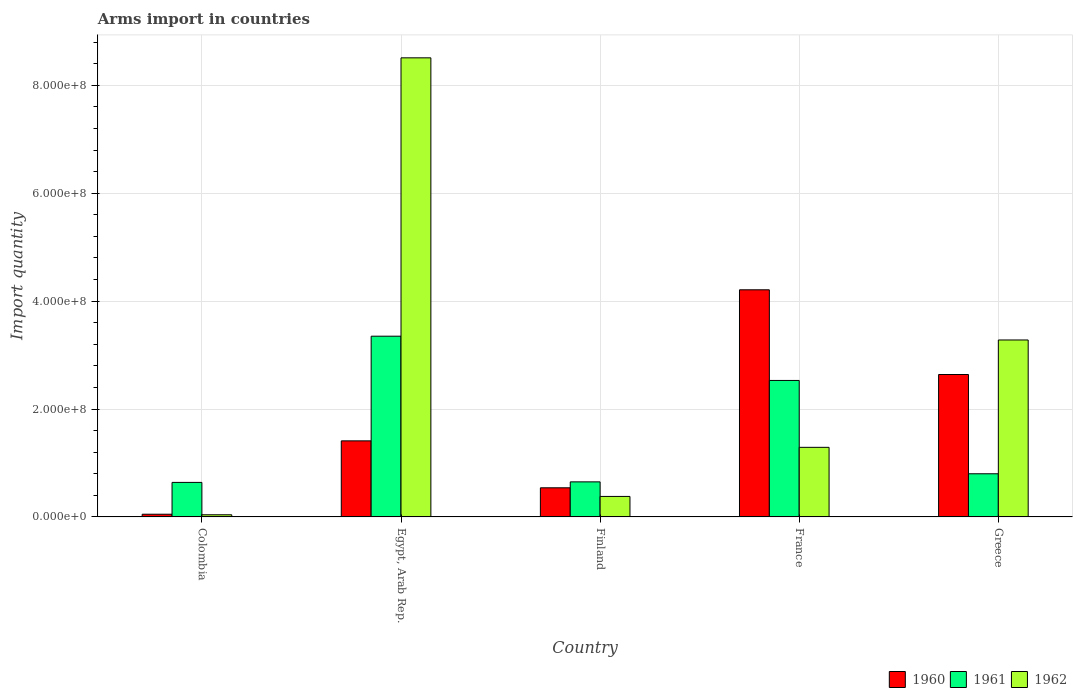How many different coloured bars are there?
Give a very brief answer. 3. How many groups of bars are there?
Keep it short and to the point. 5. Are the number of bars per tick equal to the number of legend labels?
Your answer should be compact. Yes. How many bars are there on the 5th tick from the left?
Offer a very short reply. 3. In how many cases, is the number of bars for a given country not equal to the number of legend labels?
Keep it short and to the point. 0. What is the total arms import in 1962 in Egypt, Arab Rep.?
Keep it short and to the point. 8.51e+08. Across all countries, what is the maximum total arms import in 1960?
Your response must be concise. 4.21e+08. In which country was the total arms import in 1962 maximum?
Give a very brief answer. Egypt, Arab Rep. What is the total total arms import in 1962 in the graph?
Make the answer very short. 1.35e+09. What is the difference between the total arms import in 1960 in Egypt, Arab Rep. and that in Finland?
Provide a short and direct response. 8.70e+07. What is the difference between the total arms import in 1961 in Greece and the total arms import in 1962 in Finland?
Your response must be concise. 4.20e+07. What is the average total arms import in 1960 per country?
Make the answer very short. 1.77e+08. What is the difference between the total arms import of/in 1960 and total arms import of/in 1962 in Egypt, Arab Rep.?
Your response must be concise. -7.10e+08. In how many countries, is the total arms import in 1961 greater than 120000000?
Offer a terse response. 2. What is the ratio of the total arms import in 1962 in Finland to that in France?
Give a very brief answer. 0.29. Is the total arms import in 1960 in Colombia less than that in France?
Provide a short and direct response. Yes. What is the difference between the highest and the second highest total arms import in 1960?
Your response must be concise. 1.57e+08. What is the difference between the highest and the lowest total arms import in 1961?
Offer a terse response. 2.71e+08. In how many countries, is the total arms import in 1962 greater than the average total arms import in 1962 taken over all countries?
Keep it short and to the point. 2. Is the sum of the total arms import in 1961 in France and Greece greater than the maximum total arms import in 1962 across all countries?
Provide a short and direct response. No. What does the 3rd bar from the left in Egypt, Arab Rep. represents?
Keep it short and to the point. 1962. Is it the case that in every country, the sum of the total arms import in 1962 and total arms import in 1961 is greater than the total arms import in 1960?
Provide a short and direct response. No. Are all the bars in the graph horizontal?
Your answer should be compact. No. How many countries are there in the graph?
Provide a short and direct response. 5. What is the difference between two consecutive major ticks on the Y-axis?
Make the answer very short. 2.00e+08. Are the values on the major ticks of Y-axis written in scientific E-notation?
Offer a very short reply. Yes. Does the graph contain any zero values?
Your response must be concise. No. How many legend labels are there?
Provide a succinct answer. 3. What is the title of the graph?
Make the answer very short. Arms import in countries. Does "1977" appear as one of the legend labels in the graph?
Offer a very short reply. No. What is the label or title of the Y-axis?
Ensure brevity in your answer.  Import quantity. What is the Import quantity in 1961 in Colombia?
Offer a very short reply. 6.40e+07. What is the Import quantity in 1962 in Colombia?
Provide a succinct answer. 4.00e+06. What is the Import quantity in 1960 in Egypt, Arab Rep.?
Your response must be concise. 1.41e+08. What is the Import quantity of 1961 in Egypt, Arab Rep.?
Make the answer very short. 3.35e+08. What is the Import quantity in 1962 in Egypt, Arab Rep.?
Your answer should be compact. 8.51e+08. What is the Import quantity of 1960 in Finland?
Make the answer very short. 5.40e+07. What is the Import quantity in 1961 in Finland?
Your answer should be very brief. 6.50e+07. What is the Import quantity in 1962 in Finland?
Offer a very short reply. 3.80e+07. What is the Import quantity in 1960 in France?
Make the answer very short. 4.21e+08. What is the Import quantity in 1961 in France?
Your response must be concise. 2.53e+08. What is the Import quantity of 1962 in France?
Give a very brief answer. 1.29e+08. What is the Import quantity in 1960 in Greece?
Ensure brevity in your answer.  2.64e+08. What is the Import quantity in 1961 in Greece?
Provide a short and direct response. 8.00e+07. What is the Import quantity in 1962 in Greece?
Give a very brief answer. 3.28e+08. Across all countries, what is the maximum Import quantity of 1960?
Offer a very short reply. 4.21e+08. Across all countries, what is the maximum Import quantity of 1961?
Keep it short and to the point. 3.35e+08. Across all countries, what is the maximum Import quantity of 1962?
Ensure brevity in your answer.  8.51e+08. Across all countries, what is the minimum Import quantity of 1961?
Your answer should be compact. 6.40e+07. Across all countries, what is the minimum Import quantity of 1962?
Your answer should be compact. 4.00e+06. What is the total Import quantity in 1960 in the graph?
Keep it short and to the point. 8.85e+08. What is the total Import quantity in 1961 in the graph?
Ensure brevity in your answer.  7.97e+08. What is the total Import quantity in 1962 in the graph?
Provide a short and direct response. 1.35e+09. What is the difference between the Import quantity of 1960 in Colombia and that in Egypt, Arab Rep.?
Your answer should be very brief. -1.36e+08. What is the difference between the Import quantity in 1961 in Colombia and that in Egypt, Arab Rep.?
Keep it short and to the point. -2.71e+08. What is the difference between the Import quantity of 1962 in Colombia and that in Egypt, Arab Rep.?
Ensure brevity in your answer.  -8.47e+08. What is the difference between the Import quantity in 1960 in Colombia and that in Finland?
Offer a very short reply. -4.90e+07. What is the difference between the Import quantity in 1962 in Colombia and that in Finland?
Keep it short and to the point. -3.40e+07. What is the difference between the Import quantity of 1960 in Colombia and that in France?
Provide a succinct answer. -4.16e+08. What is the difference between the Import quantity in 1961 in Colombia and that in France?
Provide a succinct answer. -1.89e+08. What is the difference between the Import quantity in 1962 in Colombia and that in France?
Make the answer very short. -1.25e+08. What is the difference between the Import quantity in 1960 in Colombia and that in Greece?
Provide a succinct answer. -2.59e+08. What is the difference between the Import quantity of 1961 in Colombia and that in Greece?
Your answer should be very brief. -1.60e+07. What is the difference between the Import quantity in 1962 in Colombia and that in Greece?
Provide a succinct answer. -3.24e+08. What is the difference between the Import quantity in 1960 in Egypt, Arab Rep. and that in Finland?
Your response must be concise. 8.70e+07. What is the difference between the Import quantity of 1961 in Egypt, Arab Rep. and that in Finland?
Offer a very short reply. 2.70e+08. What is the difference between the Import quantity in 1962 in Egypt, Arab Rep. and that in Finland?
Offer a very short reply. 8.13e+08. What is the difference between the Import quantity in 1960 in Egypt, Arab Rep. and that in France?
Give a very brief answer. -2.80e+08. What is the difference between the Import quantity of 1961 in Egypt, Arab Rep. and that in France?
Your answer should be compact. 8.20e+07. What is the difference between the Import quantity in 1962 in Egypt, Arab Rep. and that in France?
Give a very brief answer. 7.22e+08. What is the difference between the Import quantity of 1960 in Egypt, Arab Rep. and that in Greece?
Give a very brief answer. -1.23e+08. What is the difference between the Import quantity in 1961 in Egypt, Arab Rep. and that in Greece?
Offer a terse response. 2.55e+08. What is the difference between the Import quantity of 1962 in Egypt, Arab Rep. and that in Greece?
Offer a very short reply. 5.23e+08. What is the difference between the Import quantity of 1960 in Finland and that in France?
Your answer should be very brief. -3.67e+08. What is the difference between the Import quantity in 1961 in Finland and that in France?
Offer a terse response. -1.88e+08. What is the difference between the Import quantity of 1962 in Finland and that in France?
Make the answer very short. -9.10e+07. What is the difference between the Import quantity of 1960 in Finland and that in Greece?
Keep it short and to the point. -2.10e+08. What is the difference between the Import quantity of 1961 in Finland and that in Greece?
Your answer should be compact. -1.50e+07. What is the difference between the Import quantity in 1962 in Finland and that in Greece?
Ensure brevity in your answer.  -2.90e+08. What is the difference between the Import quantity of 1960 in France and that in Greece?
Offer a terse response. 1.57e+08. What is the difference between the Import quantity in 1961 in France and that in Greece?
Offer a terse response. 1.73e+08. What is the difference between the Import quantity in 1962 in France and that in Greece?
Make the answer very short. -1.99e+08. What is the difference between the Import quantity in 1960 in Colombia and the Import quantity in 1961 in Egypt, Arab Rep.?
Your answer should be compact. -3.30e+08. What is the difference between the Import quantity in 1960 in Colombia and the Import quantity in 1962 in Egypt, Arab Rep.?
Your answer should be very brief. -8.46e+08. What is the difference between the Import quantity in 1961 in Colombia and the Import quantity in 1962 in Egypt, Arab Rep.?
Your answer should be very brief. -7.87e+08. What is the difference between the Import quantity in 1960 in Colombia and the Import quantity in 1961 in Finland?
Your response must be concise. -6.00e+07. What is the difference between the Import quantity of 1960 in Colombia and the Import quantity of 1962 in Finland?
Your answer should be compact. -3.30e+07. What is the difference between the Import quantity of 1961 in Colombia and the Import quantity of 1962 in Finland?
Give a very brief answer. 2.60e+07. What is the difference between the Import quantity of 1960 in Colombia and the Import quantity of 1961 in France?
Your answer should be compact. -2.48e+08. What is the difference between the Import quantity in 1960 in Colombia and the Import quantity in 1962 in France?
Ensure brevity in your answer.  -1.24e+08. What is the difference between the Import quantity of 1961 in Colombia and the Import quantity of 1962 in France?
Offer a very short reply. -6.50e+07. What is the difference between the Import quantity of 1960 in Colombia and the Import quantity of 1961 in Greece?
Ensure brevity in your answer.  -7.50e+07. What is the difference between the Import quantity of 1960 in Colombia and the Import quantity of 1962 in Greece?
Your response must be concise. -3.23e+08. What is the difference between the Import quantity of 1961 in Colombia and the Import quantity of 1962 in Greece?
Offer a terse response. -2.64e+08. What is the difference between the Import quantity of 1960 in Egypt, Arab Rep. and the Import quantity of 1961 in Finland?
Ensure brevity in your answer.  7.60e+07. What is the difference between the Import quantity in 1960 in Egypt, Arab Rep. and the Import quantity in 1962 in Finland?
Your answer should be very brief. 1.03e+08. What is the difference between the Import quantity of 1961 in Egypt, Arab Rep. and the Import quantity of 1962 in Finland?
Ensure brevity in your answer.  2.97e+08. What is the difference between the Import quantity in 1960 in Egypt, Arab Rep. and the Import quantity in 1961 in France?
Ensure brevity in your answer.  -1.12e+08. What is the difference between the Import quantity of 1961 in Egypt, Arab Rep. and the Import quantity of 1962 in France?
Provide a short and direct response. 2.06e+08. What is the difference between the Import quantity in 1960 in Egypt, Arab Rep. and the Import quantity in 1961 in Greece?
Give a very brief answer. 6.10e+07. What is the difference between the Import quantity of 1960 in Egypt, Arab Rep. and the Import quantity of 1962 in Greece?
Provide a short and direct response. -1.87e+08. What is the difference between the Import quantity of 1960 in Finland and the Import quantity of 1961 in France?
Your answer should be compact. -1.99e+08. What is the difference between the Import quantity in 1960 in Finland and the Import quantity in 1962 in France?
Provide a short and direct response. -7.50e+07. What is the difference between the Import quantity of 1961 in Finland and the Import quantity of 1962 in France?
Keep it short and to the point. -6.40e+07. What is the difference between the Import quantity in 1960 in Finland and the Import quantity in 1961 in Greece?
Ensure brevity in your answer.  -2.60e+07. What is the difference between the Import quantity of 1960 in Finland and the Import quantity of 1962 in Greece?
Ensure brevity in your answer.  -2.74e+08. What is the difference between the Import quantity in 1961 in Finland and the Import quantity in 1962 in Greece?
Provide a short and direct response. -2.63e+08. What is the difference between the Import quantity of 1960 in France and the Import quantity of 1961 in Greece?
Your answer should be very brief. 3.41e+08. What is the difference between the Import quantity of 1960 in France and the Import quantity of 1962 in Greece?
Provide a short and direct response. 9.30e+07. What is the difference between the Import quantity of 1961 in France and the Import quantity of 1962 in Greece?
Your answer should be compact. -7.50e+07. What is the average Import quantity in 1960 per country?
Make the answer very short. 1.77e+08. What is the average Import quantity of 1961 per country?
Provide a short and direct response. 1.59e+08. What is the average Import quantity in 1962 per country?
Your response must be concise. 2.70e+08. What is the difference between the Import quantity of 1960 and Import quantity of 1961 in Colombia?
Ensure brevity in your answer.  -5.90e+07. What is the difference between the Import quantity in 1960 and Import quantity in 1962 in Colombia?
Give a very brief answer. 1.00e+06. What is the difference between the Import quantity in 1961 and Import quantity in 1962 in Colombia?
Give a very brief answer. 6.00e+07. What is the difference between the Import quantity of 1960 and Import quantity of 1961 in Egypt, Arab Rep.?
Provide a short and direct response. -1.94e+08. What is the difference between the Import quantity in 1960 and Import quantity in 1962 in Egypt, Arab Rep.?
Provide a succinct answer. -7.10e+08. What is the difference between the Import quantity in 1961 and Import quantity in 1962 in Egypt, Arab Rep.?
Provide a short and direct response. -5.16e+08. What is the difference between the Import quantity of 1960 and Import quantity of 1961 in Finland?
Your answer should be compact. -1.10e+07. What is the difference between the Import quantity of 1960 and Import quantity of 1962 in Finland?
Your response must be concise. 1.60e+07. What is the difference between the Import quantity of 1961 and Import quantity of 1962 in Finland?
Offer a terse response. 2.70e+07. What is the difference between the Import quantity of 1960 and Import quantity of 1961 in France?
Keep it short and to the point. 1.68e+08. What is the difference between the Import quantity in 1960 and Import quantity in 1962 in France?
Your answer should be very brief. 2.92e+08. What is the difference between the Import quantity of 1961 and Import quantity of 1962 in France?
Offer a very short reply. 1.24e+08. What is the difference between the Import quantity of 1960 and Import quantity of 1961 in Greece?
Provide a succinct answer. 1.84e+08. What is the difference between the Import quantity in 1960 and Import quantity in 1962 in Greece?
Provide a short and direct response. -6.40e+07. What is the difference between the Import quantity of 1961 and Import quantity of 1962 in Greece?
Your response must be concise. -2.48e+08. What is the ratio of the Import quantity in 1960 in Colombia to that in Egypt, Arab Rep.?
Offer a very short reply. 0.04. What is the ratio of the Import quantity of 1961 in Colombia to that in Egypt, Arab Rep.?
Your response must be concise. 0.19. What is the ratio of the Import quantity of 1962 in Colombia to that in Egypt, Arab Rep.?
Ensure brevity in your answer.  0. What is the ratio of the Import quantity of 1960 in Colombia to that in Finland?
Provide a succinct answer. 0.09. What is the ratio of the Import quantity of 1961 in Colombia to that in Finland?
Your answer should be compact. 0.98. What is the ratio of the Import quantity of 1962 in Colombia to that in Finland?
Give a very brief answer. 0.11. What is the ratio of the Import quantity in 1960 in Colombia to that in France?
Make the answer very short. 0.01. What is the ratio of the Import quantity in 1961 in Colombia to that in France?
Offer a very short reply. 0.25. What is the ratio of the Import quantity of 1962 in Colombia to that in France?
Offer a very short reply. 0.03. What is the ratio of the Import quantity in 1960 in Colombia to that in Greece?
Provide a succinct answer. 0.02. What is the ratio of the Import quantity of 1961 in Colombia to that in Greece?
Your answer should be very brief. 0.8. What is the ratio of the Import quantity of 1962 in Colombia to that in Greece?
Ensure brevity in your answer.  0.01. What is the ratio of the Import quantity in 1960 in Egypt, Arab Rep. to that in Finland?
Ensure brevity in your answer.  2.61. What is the ratio of the Import quantity in 1961 in Egypt, Arab Rep. to that in Finland?
Your answer should be compact. 5.15. What is the ratio of the Import quantity of 1962 in Egypt, Arab Rep. to that in Finland?
Keep it short and to the point. 22.39. What is the ratio of the Import quantity of 1960 in Egypt, Arab Rep. to that in France?
Keep it short and to the point. 0.33. What is the ratio of the Import quantity in 1961 in Egypt, Arab Rep. to that in France?
Keep it short and to the point. 1.32. What is the ratio of the Import quantity of 1962 in Egypt, Arab Rep. to that in France?
Your answer should be compact. 6.6. What is the ratio of the Import quantity of 1960 in Egypt, Arab Rep. to that in Greece?
Offer a terse response. 0.53. What is the ratio of the Import quantity in 1961 in Egypt, Arab Rep. to that in Greece?
Offer a very short reply. 4.19. What is the ratio of the Import quantity of 1962 in Egypt, Arab Rep. to that in Greece?
Your answer should be very brief. 2.59. What is the ratio of the Import quantity of 1960 in Finland to that in France?
Your answer should be compact. 0.13. What is the ratio of the Import quantity of 1961 in Finland to that in France?
Make the answer very short. 0.26. What is the ratio of the Import quantity of 1962 in Finland to that in France?
Your response must be concise. 0.29. What is the ratio of the Import quantity in 1960 in Finland to that in Greece?
Make the answer very short. 0.2. What is the ratio of the Import quantity of 1961 in Finland to that in Greece?
Provide a short and direct response. 0.81. What is the ratio of the Import quantity in 1962 in Finland to that in Greece?
Your answer should be very brief. 0.12. What is the ratio of the Import quantity in 1960 in France to that in Greece?
Offer a very short reply. 1.59. What is the ratio of the Import quantity of 1961 in France to that in Greece?
Your answer should be compact. 3.16. What is the ratio of the Import quantity in 1962 in France to that in Greece?
Provide a short and direct response. 0.39. What is the difference between the highest and the second highest Import quantity in 1960?
Offer a very short reply. 1.57e+08. What is the difference between the highest and the second highest Import quantity in 1961?
Keep it short and to the point. 8.20e+07. What is the difference between the highest and the second highest Import quantity of 1962?
Make the answer very short. 5.23e+08. What is the difference between the highest and the lowest Import quantity of 1960?
Make the answer very short. 4.16e+08. What is the difference between the highest and the lowest Import quantity in 1961?
Keep it short and to the point. 2.71e+08. What is the difference between the highest and the lowest Import quantity of 1962?
Provide a succinct answer. 8.47e+08. 